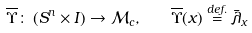<formula> <loc_0><loc_0><loc_500><loc_500>\overline { \Upsilon } \colon \, ( S ^ { n } \times I ) \rightarrow \mathcal { M } _ { c } , \quad \overline { \Upsilon } ( x ) \overset { d e f . } { = } \bar { \lambda } _ { x }</formula> 